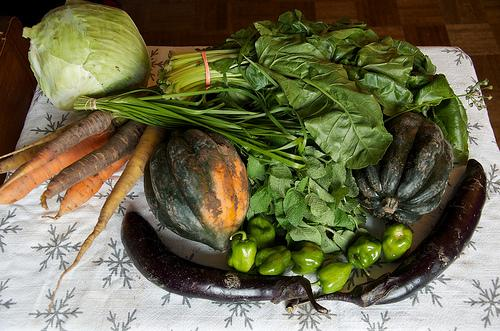Describe any patterns or unique features present on the tablecloth in the image. The white tablecloth in the image has a subtle gray snowflake print on it, which complements the vegetables resting on it. Mention the way the vegetables are positioned in relation to each other. The peppers, eggplant, carrots, and cabbage are laid out together in a casual arrangement on the tablecloth. Explain the overall vibe and atmosphere of the image. A homely and organic feel emanates from the image, with an assortment of natural, home-grown, and untouched vegetables. Write a concise description of the overall image. A variety of vegetables, including green peppers, eggplant, carrots, and cabbage, lay on a snowflake-patterned white tablecloth. Briefly describe the most prominent objects present in the image. Various vegetables including green peppers, eggplant, carrots, and cabbage are displayed on a white, snowflake-patterned tablecloth. Mention the colors of the vegetables and their arrangement in the image. Green peppers, purple eggplant, orange carrots, and light green cabbage are arranged together on a tabletop. Mention the different types of vegetables and their number as seen in the image. Eight green peppers, a single eggplant, several carrots, and a cabbage are featured in the image. Describe the setting where the vegetables are placed in the image. The vegetables are arranged on a white tablecloth with a snowflake design which is placed on top of a wooden table. Describe any noteworthy details about the vegetables in the image. Some vegetables, like the carrots, have a pink rubber band tied around them while the eggplant has a few scars, and the cabbage is round and light green in color. In a poetic manner, describe the image consisting of vegetables. A symphony of colors reside, as the choir of vegetables sings; green peppers, purple eggplant, and orange carrots embrace in a dance upon the snowflake-patterned cloth. 